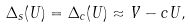Convert formula to latex. <formula><loc_0><loc_0><loc_500><loc_500>\Delta _ { s } ( U ) = \Delta _ { c } ( U ) \approx V - c U ,</formula> 